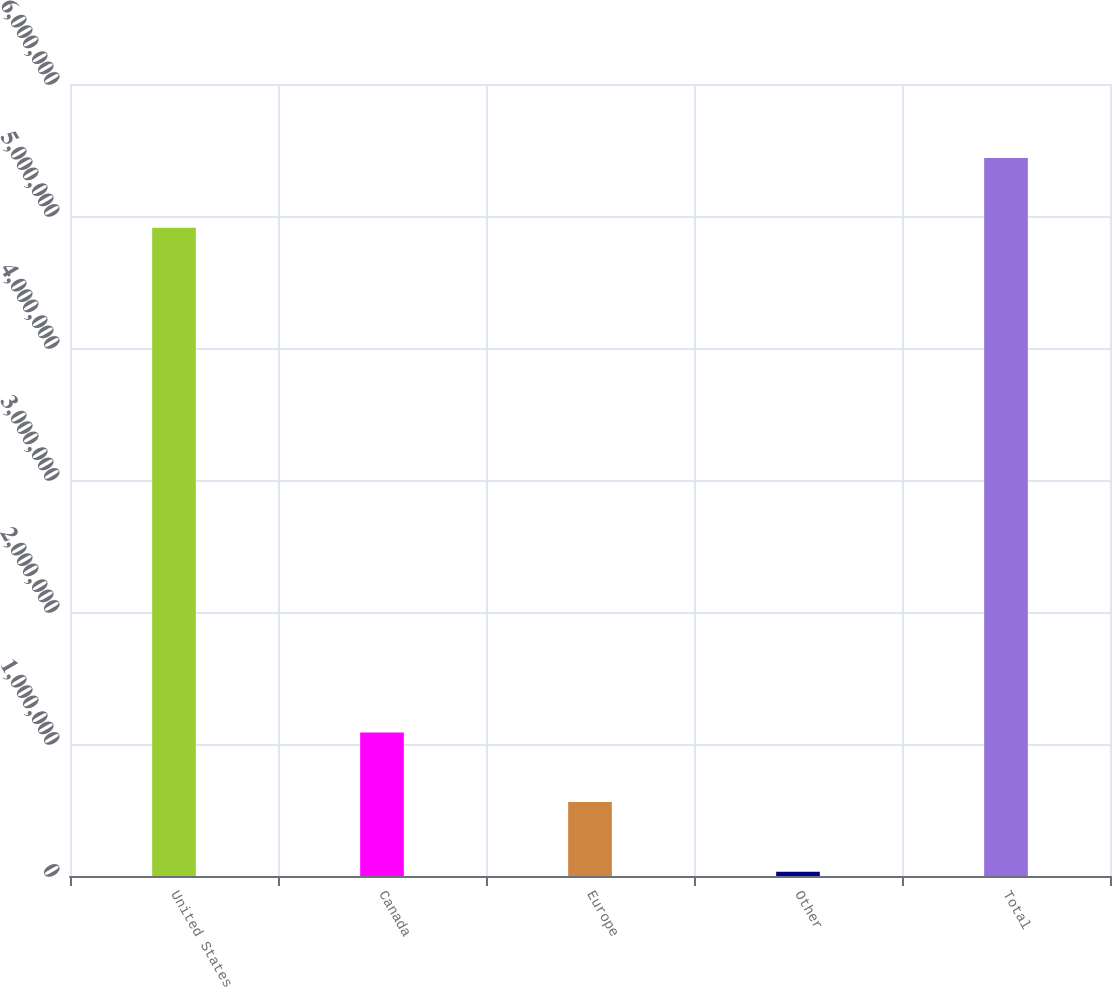<chart> <loc_0><loc_0><loc_500><loc_500><bar_chart><fcel>United States<fcel>Canada<fcel>Europe<fcel>Other<fcel>Total<nl><fcel>4.9113e+06<fcel>1.08753e+06<fcel>559950<fcel>32371<fcel>5.43888e+06<nl></chart> 